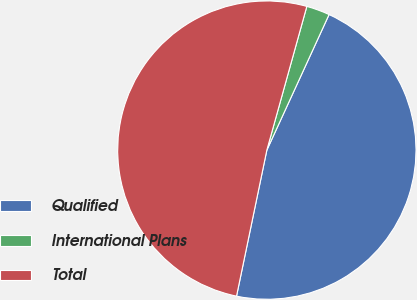Convert chart to OTSL. <chart><loc_0><loc_0><loc_500><loc_500><pie_chart><fcel>Qualified<fcel>International Plans<fcel>Total<nl><fcel>46.41%<fcel>2.53%<fcel>51.06%<nl></chart> 